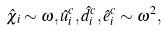Convert formula to latex. <formula><loc_0><loc_0><loc_500><loc_500>\hat { \chi } _ { i } \sim \omega , \hat { u } ^ { c } _ { i } , \hat { d } ^ { c } _ { i } , \hat { e } ^ { c } _ { i } \sim \omega ^ { 2 } ,</formula> 